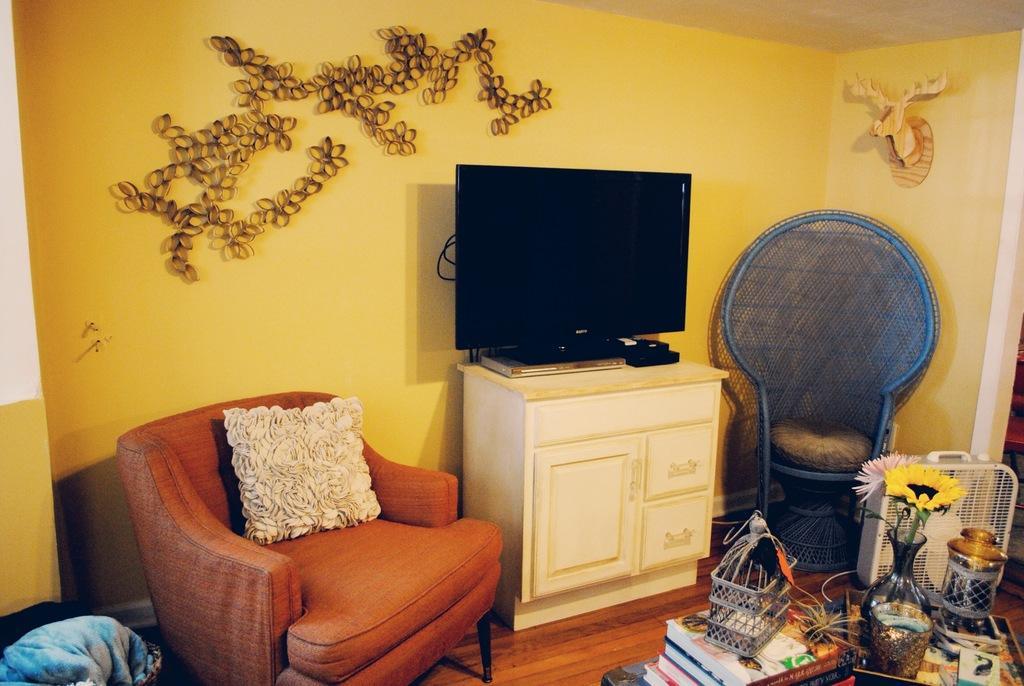Could you give a brief overview of what you see in this image? There are sofa chair,TV and some books on table in a room. 